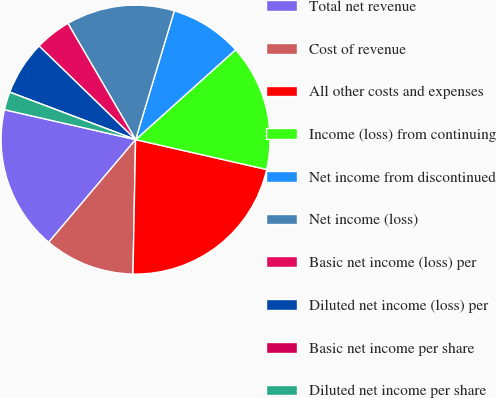Convert chart to OTSL. <chart><loc_0><loc_0><loc_500><loc_500><pie_chart><fcel>Total net revenue<fcel>Cost of revenue<fcel>All other costs and expenses<fcel>Income (loss) from continuing<fcel>Net income from discontinued<fcel>Net income (loss)<fcel>Basic net income (loss) per<fcel>Diluted net income (loss) per<fcel>Basic net income per share<fcel>Diluted net income per share<nl><fcel>17.39%<fcel>10.87%<fcel>21.74%<fcel>15.22%<fcel>8.7%<fcel>13.04%<fcel>4.35%<fcel>6.52%<fcel>0.0%<fcel>2.17%<nl></chart> 